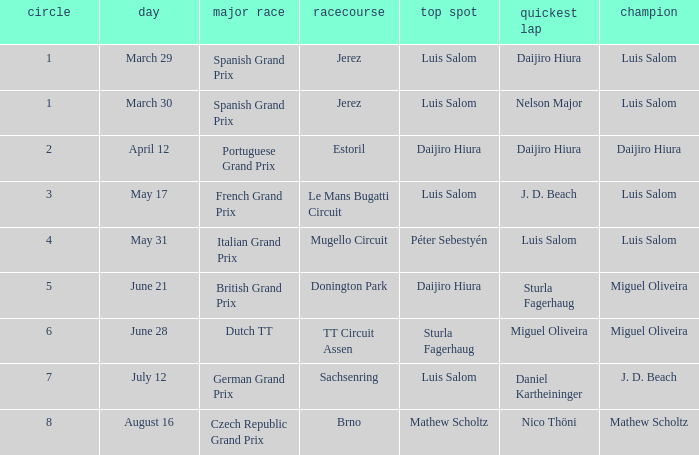What grand prixs did Daijiro Hiura win?  Portuguese Grand Prix. 